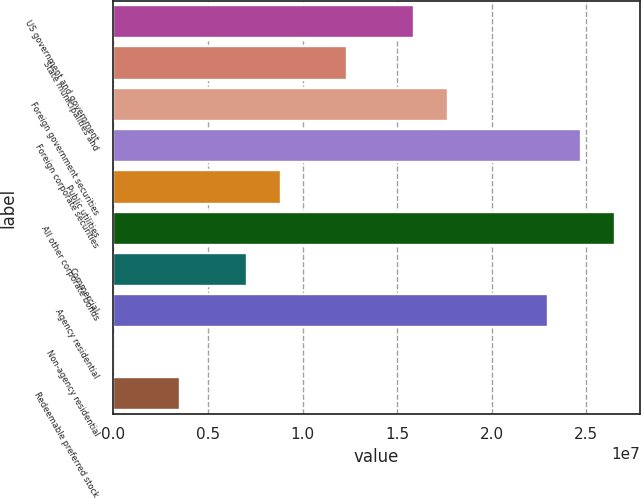<chart> <loc_0><loc_0><loc_500><loc_500><bar_chart><fcel>US government and government<fcel>State municipalities and<fcel>Foreign government securities<fcel>Foreign corporate securities<fcel>Public utilities<fcel>All other corporate bonds<fcel>Commercial<fcel>Agency residential<fcel>Non-agency residential<fcel>Redeemable preferred stock<nl><fcel>1.5905e+07<fcel>1.23708e+07<fcel>1.76722e+07<fcel>2.47407e+07<fcel>8.83654e+06<fcel>2.65078e+07<fcel>7.06941e+06<fcel>2.29736e+07<fcel>898<fcel>3.53515e+06<nl></chart> 